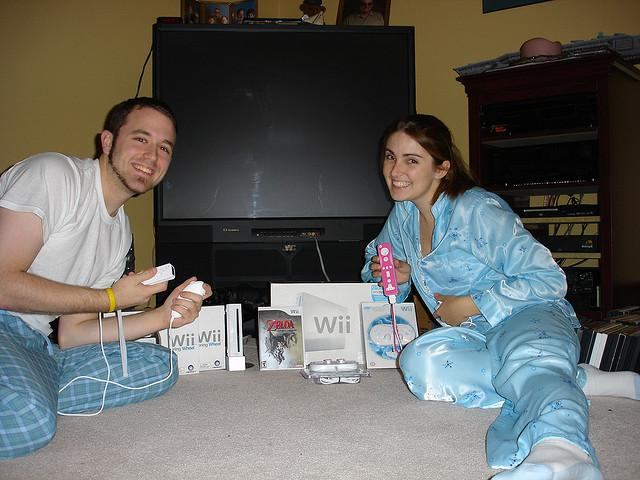Who is the main male character in that video game?

Choices:
A) link
B) kong
C) zelda
D) mario link 